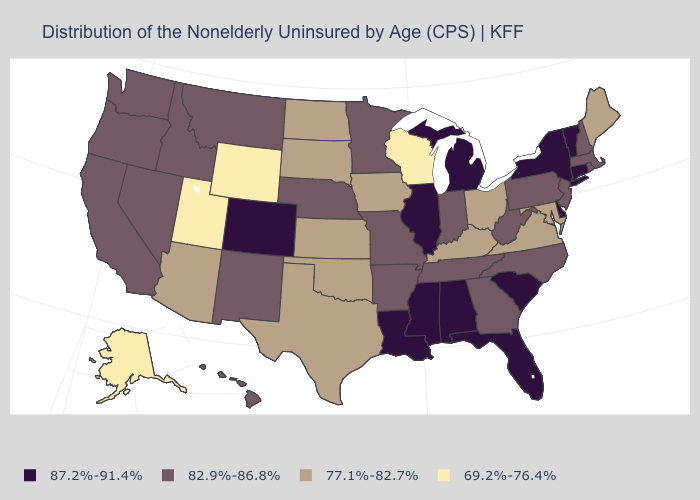Does Maryland have the same value as Maine?
Write a very short answer. Yes. How many symbols are there in the legend?
Be succinct. 4. Name the states that have a value in the range 69.2%-76.4%?
Give a very brief answer. Alaska, Utah, Wisconsin, Wyoming. Among the states that border Pennsylvania , which have the highest value?
Concise answer only. Delaware, New York. What is the value of Arizona?
Answer briefly. 77.1%-82.7%. Among the states that border New Jersey , does New York have the lowest value?
Concise answer only. No. Does New Mexico have the highest value in the West?
Quick response, please. No. Does the map have missing data?
Write a very short answer. No. What is the value of Vermont?
Short answer required. 87.2%-91.4%. Name the states that have a value in the range 69.2%-76.4%?
Write a very short answer. Alaska, Utah, Wisconsin, Wyoming. What is the value of Nebraska?
Quick response, please. 82.9%-86.8%. Name the states that have a value in the range 69.2%-76.4%?
Keep it brief. Alaska, Utah, Wisconsin, Wyoming. What is the value of Missouri?
Give a very brief answer. 82.9%-86.8%. Among the states that border Michigan , does Indiana have the highest value?
Keep it brief. Yes. Name the states that have a value in the range 69.2%-76.4%?
Give a very brief answer. Alaska, Utah, Wisconsin, Wyoming. 